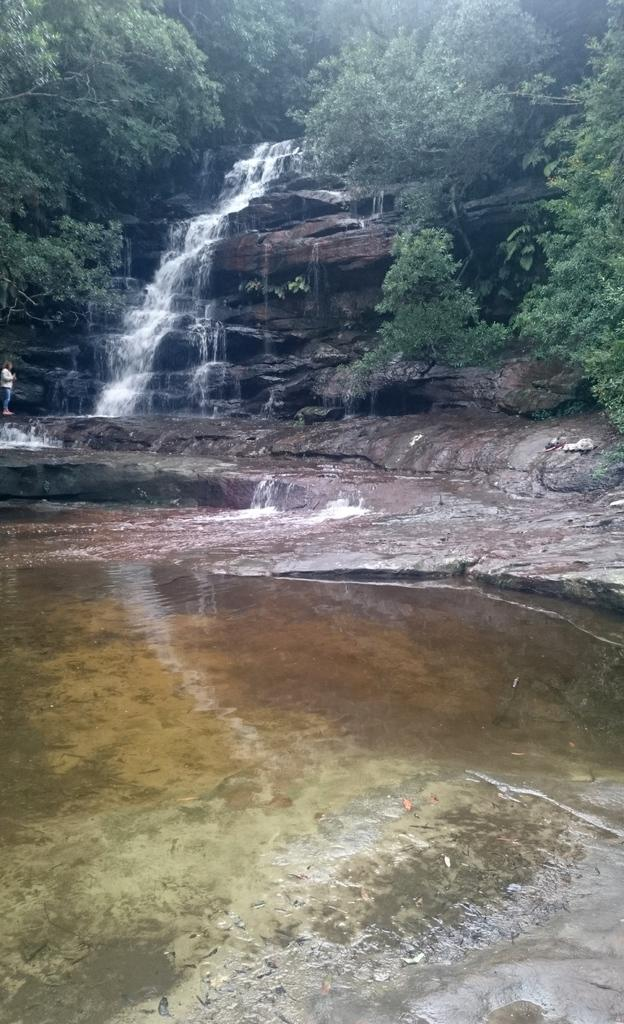What is present at the bottom of the image? There is water at the bottom of the image. What can be seen in the middle of the image? There is a waterfall in the middle of the image. What type of vegetation is visible in the background of the image? There are trees in the background of the image. How many hills can be seen in the image? There are no hills present in the image; it features a waterfall and trees. What type of cushion is used to support the waterfall in the image? There is no cushion present in the image; the waterfall is a natural formation. 